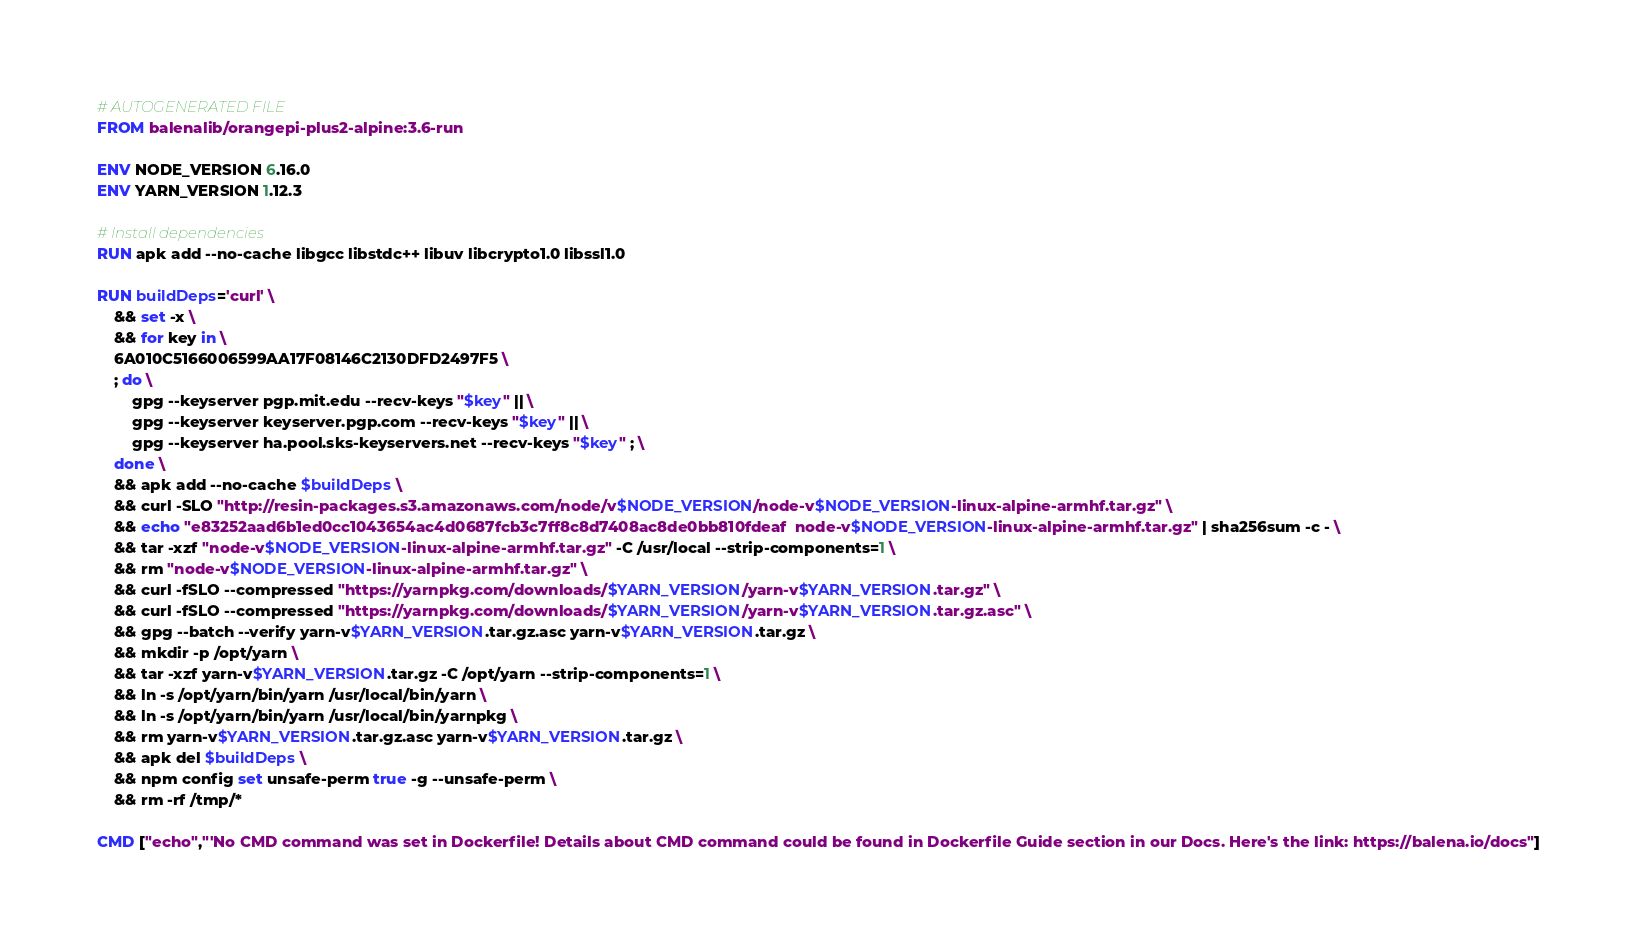Convert code to text. <code><loc_0><loc_0><loc_500><loc_500><_Dockerfile_># AUTOGENERATED FILE
FROM balenalib/orangepi-plus2-alpine:3.6-run

ENV NODE_VERSION 6.16.0
ENV YARN_VERSION 1.12.3

# Install dependencies
RUN apk add --no-cache libgcc libstdc++ libuv libcrypto1.0 libssl1.0

RUN buildDeps='curl' \
	&& set -x \
	&& for key in \
	6A010C5166006599AA17F08146C2130DFD2497F5 \
	; do \
		gpg --keyserver pgp.mit.edu --recv-keys "$key" || \
		gpg --keyserver keyserver.pgp.com --recv-keys "$key" || \
		gpg --keyserver ha.pool.sks-keyservers.net --recv-keys "$key" ; \
	done \
	&& apk add --no-cache $buildDeps \
	&& curl -SLO "http://resin-packages.s3.amazonaws.com/node/v$NODE_VERSION/node-v$NODE_VERSION-linux-alpine-armhf.tar.gz" \
	&& echo "e83252aad6b1ed0cc1043654ac4d0687fcb3c7ff8c8d7408ac8de0bb810fdeaf  node-v$NODE_VERSION-linux-alpine-armhf.tar.gz" | sha256sum -c - \
	&& tar -xzf "node-v$NODE_VERSION-linux-alpine-armhf.tar.gz" -C /usr/local --strip-components=1 \
	&& rm "node-v$NODE_VERSION-linux-alpine-armhf.tar.gz" \
	&& curl -fSLO --compressed "https://yarnpkg.com/downloads/$YARN_VERSION/yarn-v$YARN_VERSION.tar.gz" \
	&& curl -fSLO --compressed "https://yarnpkg.com/downloads/$YARN_VERSION/yarn-v$YARN_VERSION.tar.gz.asc" \
	&& gpg --batch --verify yarn-v$YARN_VERSION.tar.gz.asc yarn-v$YARN_VERSION.tar.gz \
	&& mkdir -p /opt/yarn \
	&& tar -xzf yarn-v$YARN_VERSION.tar.gz -C /opt/yarn --strip-components=1 \
	&& ln -s /opt/yarn/bin/yarn /usr/local/bin/yarn \
	&& ln -s /opt/yarn/bin/yarn /usr/local/bin/yarnpkg \
	&& rm yarn-v$YARN_VERSION.tar.gz.asc yarn-v$YARN_VERSION.tar.gz \
	&& apk del $buildDeps \
	&& npm config set unsafe-perm true -g --unsafe-perm \
	&& rm -rf /tmp/*

CMD ["echo","'No CMD command was set in Dockerfile! Details about CMD command could be found in Dockerfile Guide section in our Docs. Here's the link: https://balena.io/docs"]</code> 